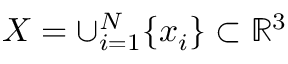<formula> <loc_0><loc_0><loc_500><loc_500>X = \cup _ { i = 1 } ^ { N } \{ x _ { i } \} \subset \mathbb { R } ^ { 3 }</formula> 